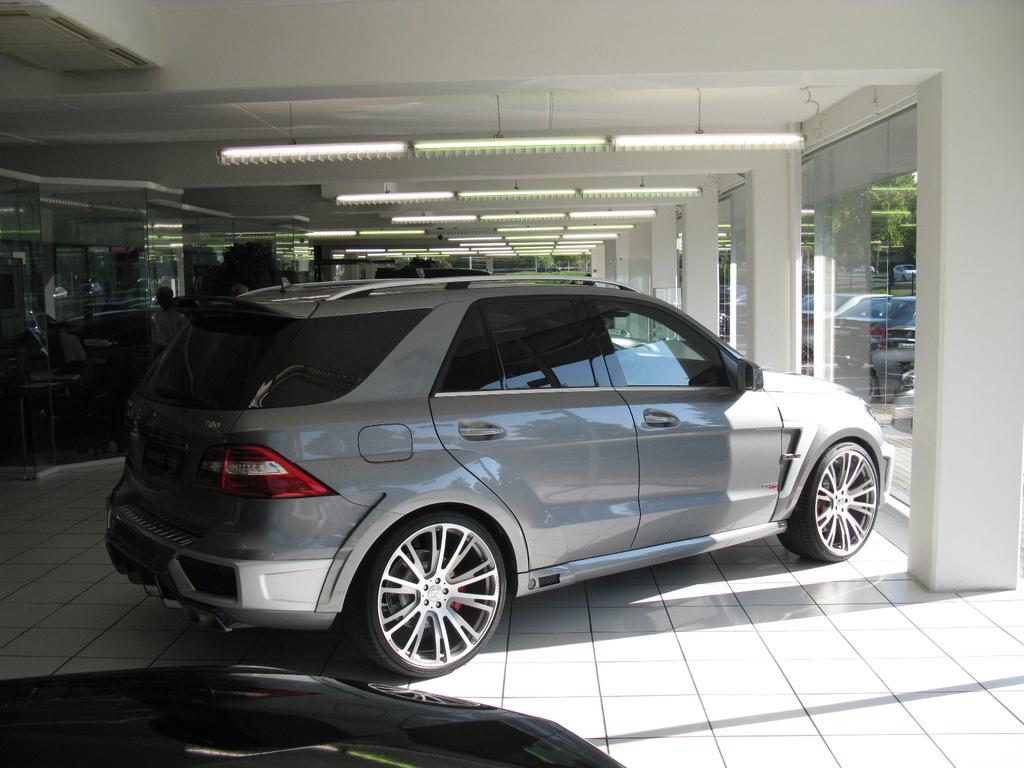What types of objects can be seen in the image? There are vehicles, people, and other objects in the image. Can you describe the vehicles in the image? Unfortunately, the provided facts do not give specific details about the vehicles. What can you tell me about the people in the image? There are people in the image, but the facts do not provide any details about them. What is the lighting situation in the image? There are lights on the ceiling in the image. What type of desk can be seen in the image? There is no desk present in the image. How do the people in the image maintain their balance? The provided facts do not give any information about the people's balance or actions. 